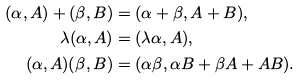<formula> <loc_0><loc_0><loc_500><loc_500>( \alpha , A ) + ( \beta , B ) & = ( \alpha + \beta , A + B ) , \\ \lambda ( \alpha , A ) & = ( \lambda \alpha , A ) , \\ ( \alpha , A ) ( \beta , B ) & = ( \alpha \beta , \alpha B + \beta A + A B ) .</formula> 